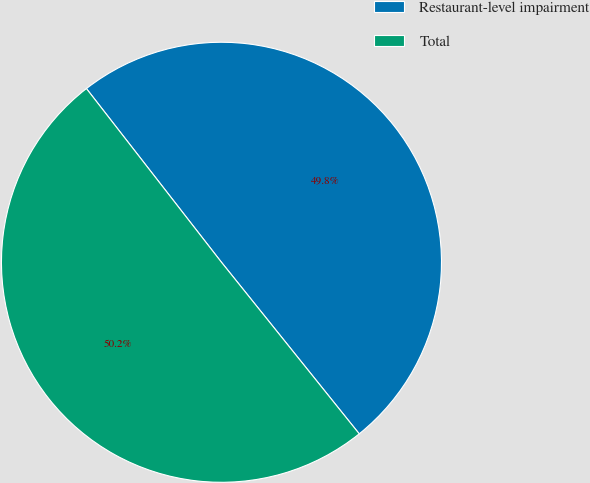Convert chart to OTSL. <chart><loc_0><loc_0><loc_500><loc_500><pie_chart><fcel>Restaurant-level impairment<fcel>Total<nl><fcel>49.75%<fcel>50.25%<nl></chart> 